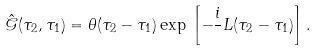<formula> <loc_0><loc_0><loc_500><loc_500>\hat { \mathcal { G } } ( \tau _ { 2 } , \tau _ { 1 } ) = \theta ( \tau _ { 2 } - \tau _ { 1 } ) \exp \, \left [ - \frac { i } { } L ( \tau _ { 2 } - \tau _ { 1 } ) \right ] .</formula> 